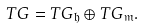<formula> <loc_0><loc_0><loc_500><loc_500>T G = T G _ { \mathfrak { h } } \oplus T G _ { \mathfrak { m } } .</formula> 